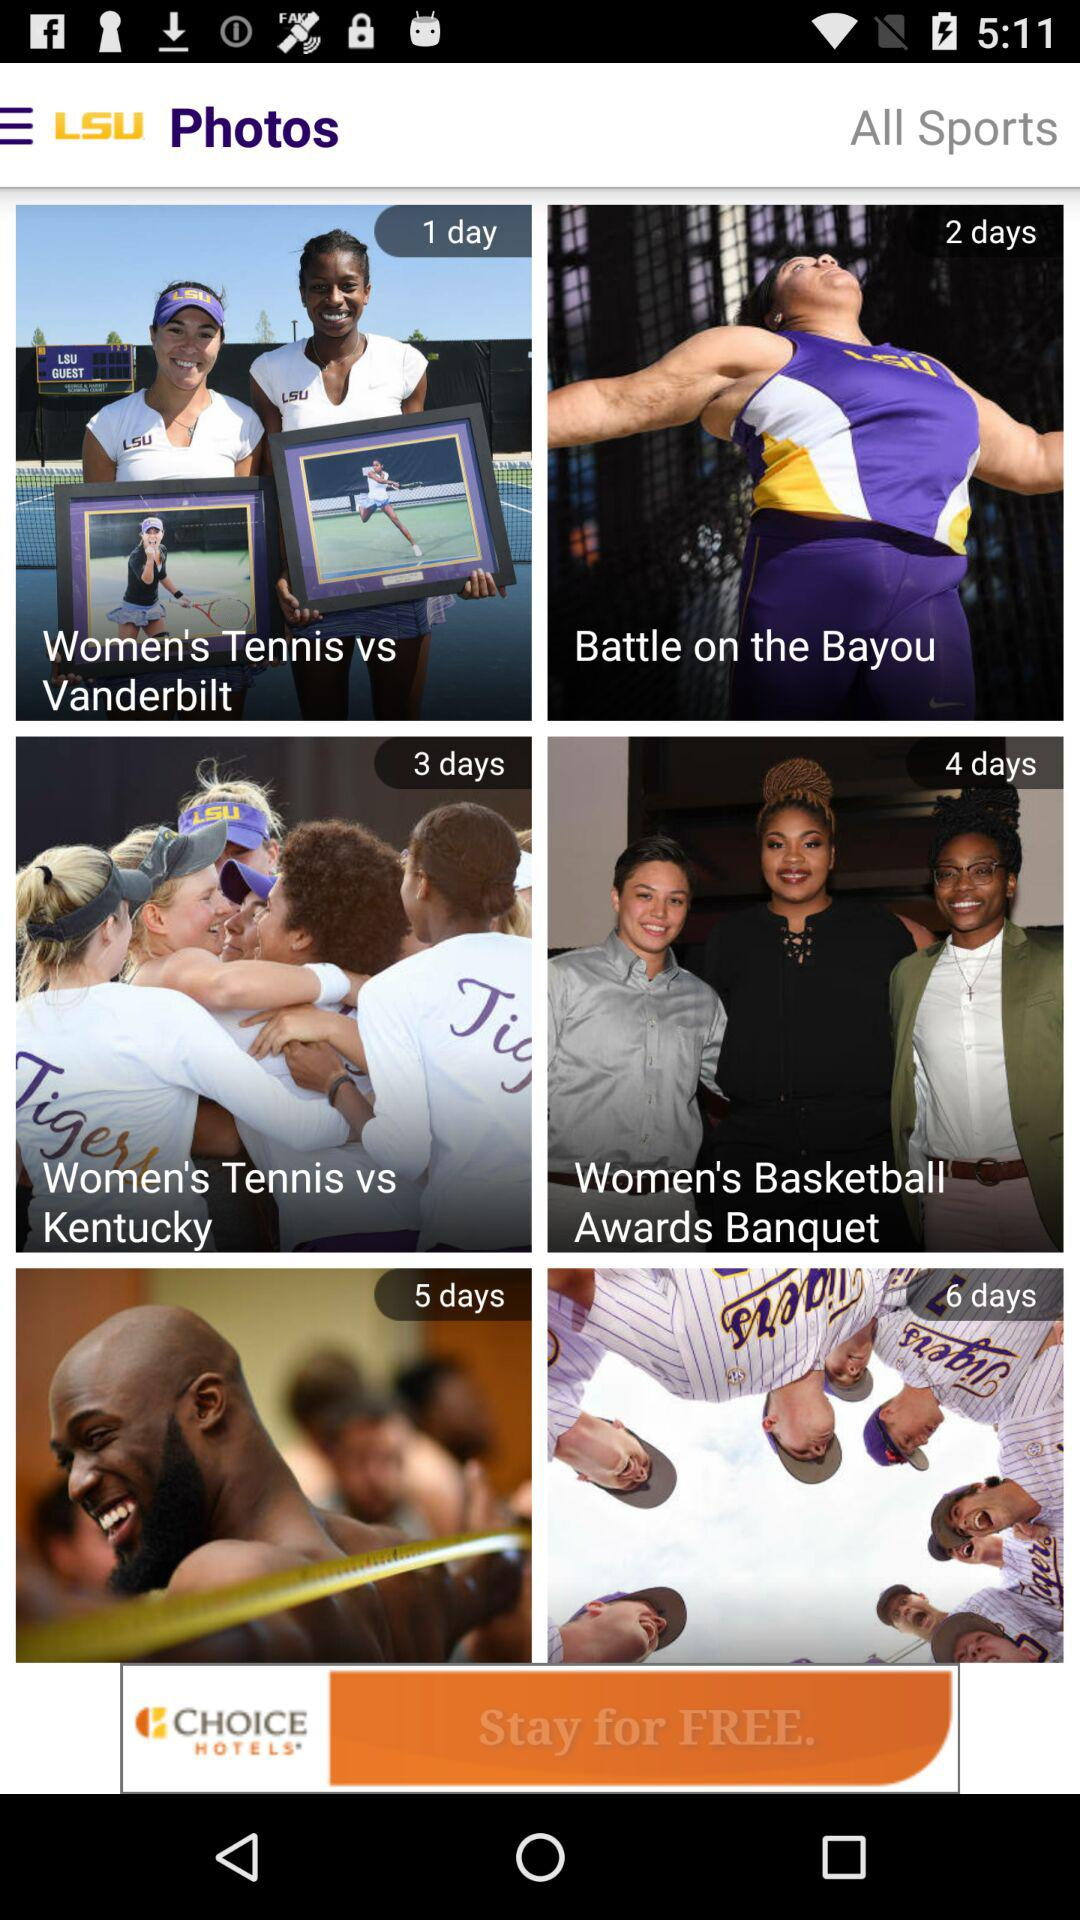How many days are there between the first and last events?
Answer the question using a single word or phrase. 5 